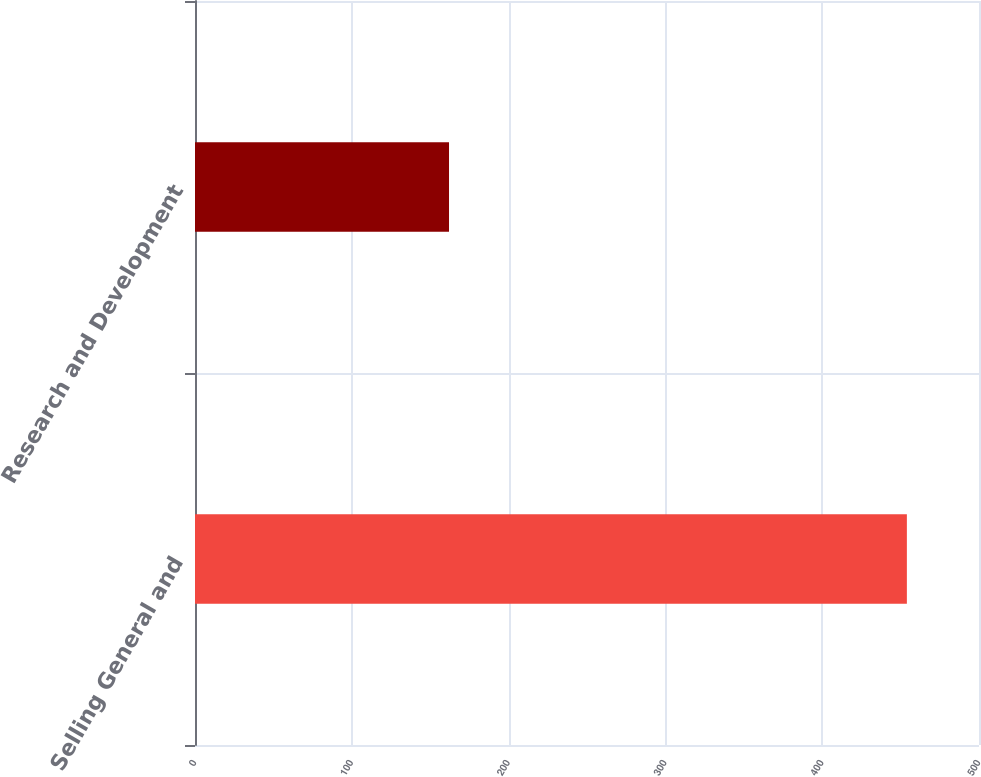Convert chart. <chart><loc_0><loc_0><loc_500><loc_500><bar_chart><fcel>Selling General and<fcel>Research and Development<nl><fcel>454<fcel>162<nl></chart> 